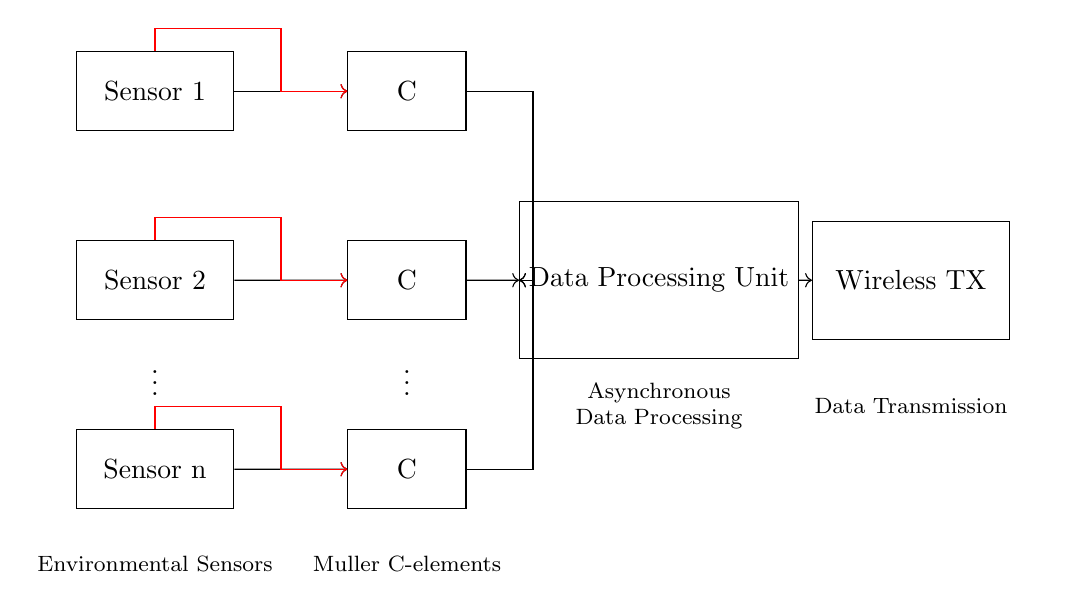What components are used in this circuit? The diagram shows environmental sensors, Muller C-elements, a Data Processing Unit, and a Wireless Transmitter. These represent the primary components of the sensor network.
Answer: Environmental sensors, Muller C-elements, Data Processing Unit, Wireless Transmitter How many environmental sensors are illustrated? The diagram displays three distinct environmental sensors, each represented by a rectangular shape. However, it indicates that there can be an arbitrary 'n' number of sensors.
Answer: Three What is the function of the Muller C-element in this circuit? The Muller C-elements are used to ensure that the output changes only when all inputs are stable, which is important for the asynchronous operation of the circuit.
Answer: Synchronization How do the environmental sensors connect to the Data Processing Unit? Each sensor sends its signal to an associated Muller C-element, which then routes the signals to the Data Processing Unit, showing a mix of direct and branching connections.
Answer: Through Muller C-elements How does the circuit ensure acknowledgment signals are sent back to each sensor? The diagram indicates that acknowledgment signals are directed back from the Muller C-elements to each environmental sensor, which is crucial for confirming the receipt of data.
Answer: Through feedback paths What type of circuit is this? The circuit is classified as an asynchronous circuit because it utilizes elements like the Muller C-element for processing data without relying on a global clock signal.
Answer: Asynchronous 